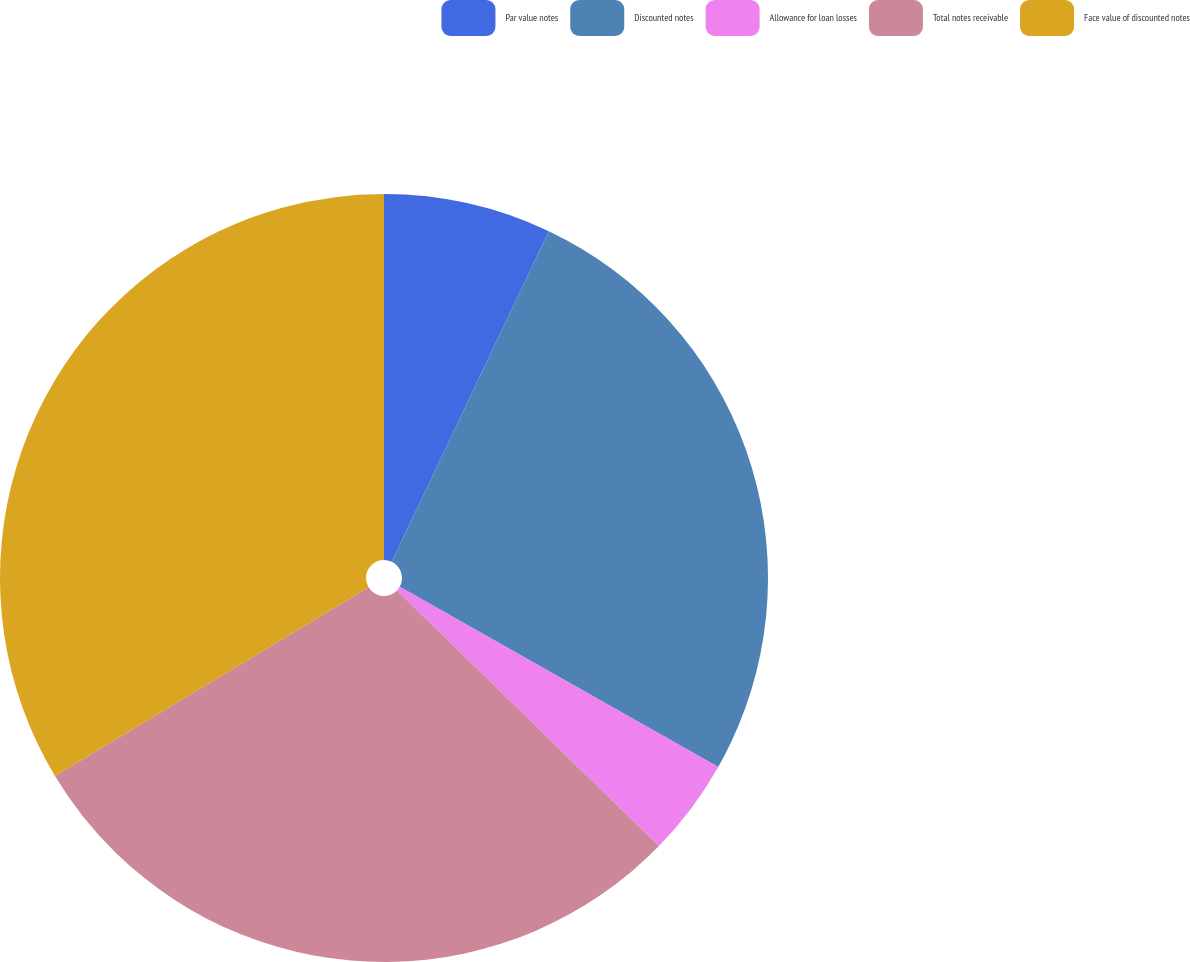Convert chart to OTSL. <chart><loc_0><loc_0><loc_500><loc_500><pie_chart><fcel>Par value notes<fcel>Discounted notes<fcel>Allowance for loan losses<fcel>Total notes receivable<fcel>Face value of discounted notes<nl><fcel>7.06%<fcel>26.13%<fcel>4.11%<fcel>29.08%<fcel>33.62%<nl></chart> 